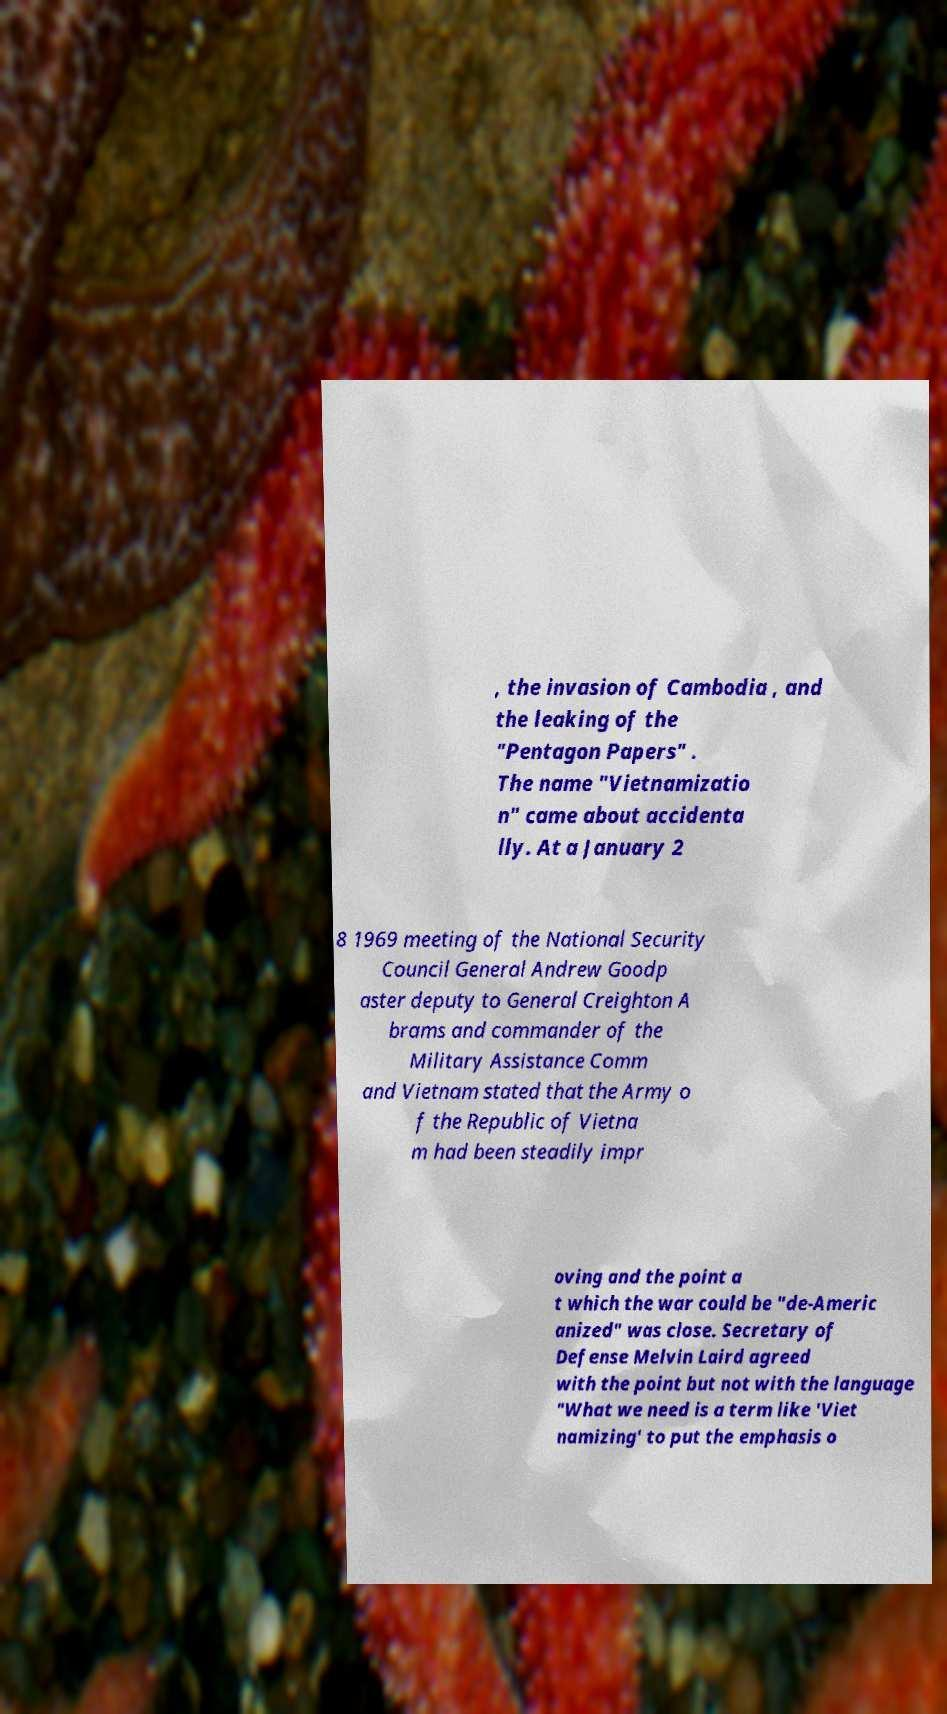What messages or text are displayed in this image? I need them in a readable, typed format. , the invasion of Cambodia , and the leaking of the "Pentagon Papers" . The name "Vietnamizatio n" came about accidenta lly. At a January 2 8 1969 meeting of the National Security Council General Andrew Goodp aster deputy to General Creighton A brams and commander of the Military Assistance Comm and Vietnam stated that the Army o f the Republic of Vietna m had been steadily impr oving and the point a t which the war could be "de-Americ anized" was close. Secretary of Defense Melvin Laird agreed with the point but not with the language "What we need is a term like 'Viet namizing' to put the emphasis o 